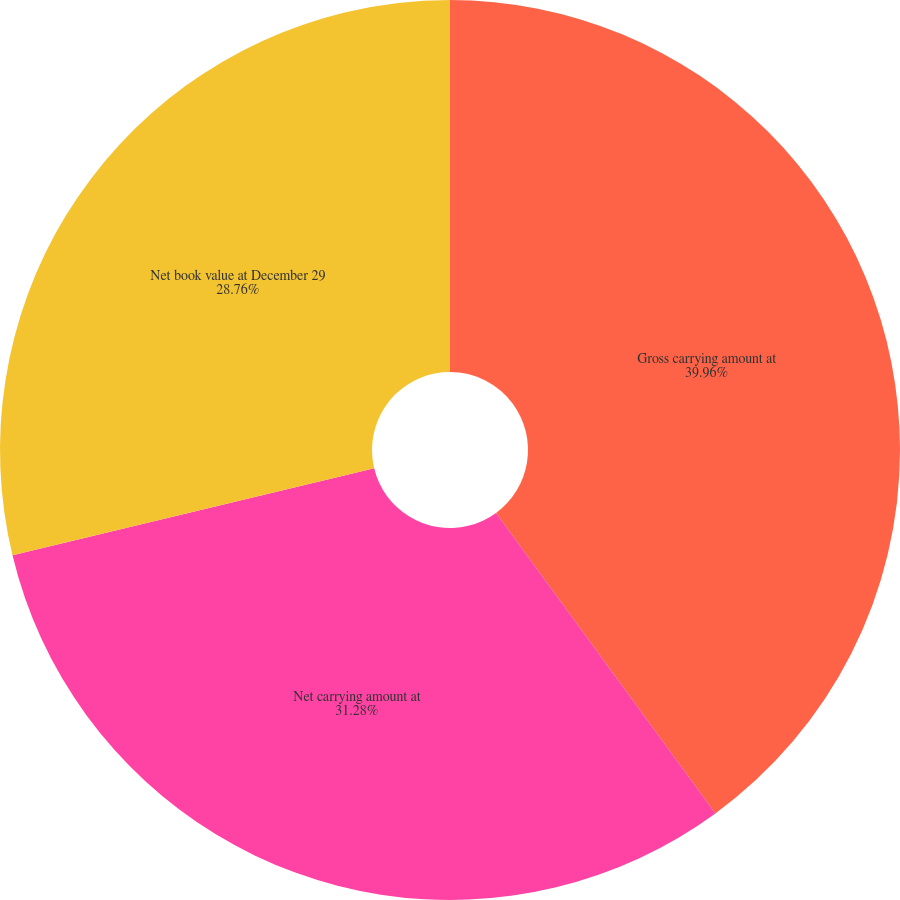Convert chart to OTSL. <chart><loc_0><loc_0><loc_500><loc_500><pie_chart><fcel>Gross carrying amount at<fcel>Net carrying amount at<fcel>Net book value at December 29<nl><fcel>39.96%<fcel>31.28%<fcel>28.76%<nl></chart> 